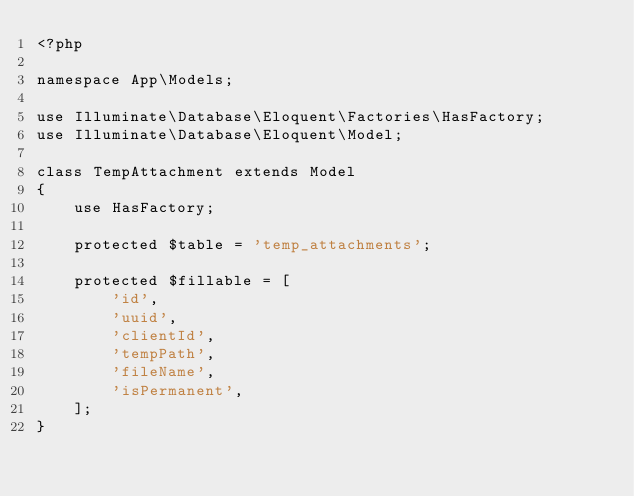<code> <loc_0><loc_0><loc_500><loc_500><_PHP_><?php

namespace App\Models;

use Illuminate\Database\Eloquent\Factories\HasFactory;
use Illuminate\Database\Eloquent\Model;

class TempAttachment extends Model
{
    use HasFactory;

    protected $table = 'temp_attachments';

    protected $fillable = [
        'id',
        'uuid',
        'clientId',
        'tempPath',
        'fileName',
        'isPermanent',
    ];
}
</code> 